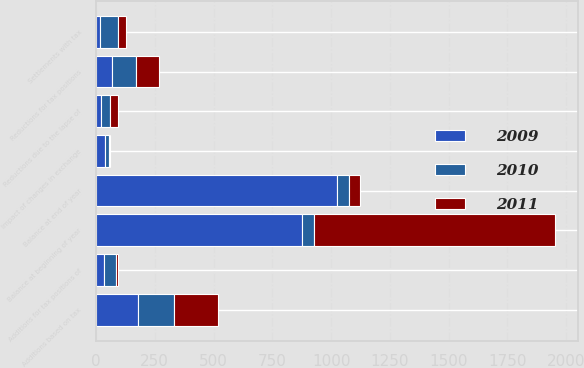Convert chart to OTSL. <chart><loc_0><loc_0><loc_500><loc_500><stacked_bar_chart><ecel><fcel>Balance at beginning of year<fcel>Additions based on tax<fcel>Additions for tax positions of<fcel>Impact of changes in exchange<fcel>Settlements with tax<fcel>Reductions for tax positions<fcel>Reductions due to the lapse of<fcel>Balance at end of year<nl><fcel>2010<fcel>49<fcel>153<fcel>49<fcel>18<fcel>77<fcel>102<fcel>38<fcel>49<nl><fcel>2011<fcel>1026<fcel>190<fcel>8<fcel>3<fcel>36<fcel>99<fcel>36<fcel>49<nl><fcel>2009<fcel>877<fcel>178<fcel>36<fcel>39<fcel>16<fcel>68<fcel>20<fcel>1026<nl></chart> 